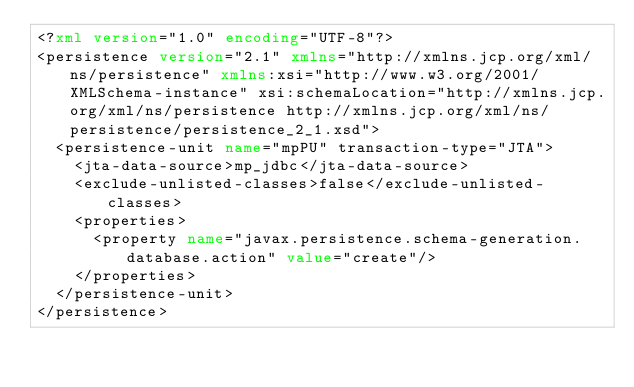Convert code to text. <code><loc_0><loc_0><loc_500><loc_500><_XML_><?xml version="1.0" encoding="UTF-8"?>
<persistence version="2.1" xmlns="http://xmlns.jcp.org/xml/ns/persistence" xmlns:xsi="http://www.w3.org/2001/XMLSchema-instance" xsi:schemaLocation="http://xmlns.jcp.org/xml/ns/persistence http://xmlns.jcp.org/xml/ns/persistence/persistence_2_1.xsd">
  <persistence-unit name="mpPU" transaction-type="JTA">
    <jta-data-source>mp_jdbc</jta-data-source>
    <exclude-unlisted-classes>false</exclude-unlisted-classes>
    <properties>
      <property name="javax.persistence.schema-generation.database.action" value="create"/>
    </properties>
  </persistence-unit>
</persistence>
</code> 